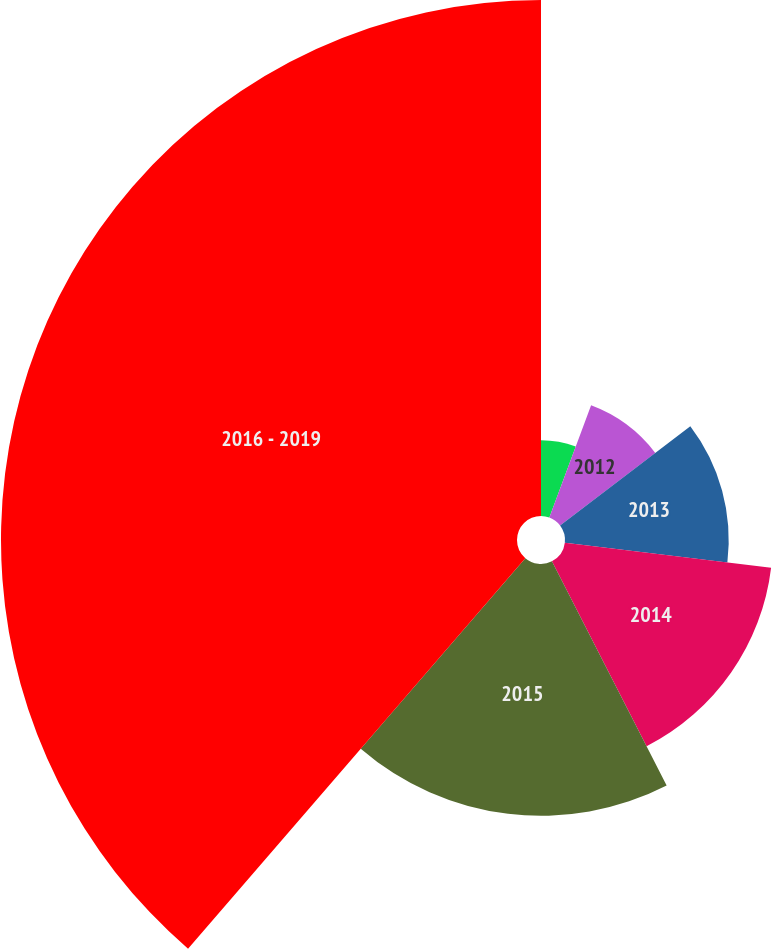<chart> <loc_0><loc_0><loc_500><loc_500><pie_chart><fcel>2011<fcel>2012<fcel>2013<fcel>2014<fcel>2015<fcel>2016 - 2019<nl><fcel>5.67%<fcel>8.97%<fcel>12.27%<fcel>15.57%<fcel>18.87%<fcel>38.67%<nl></chart> 